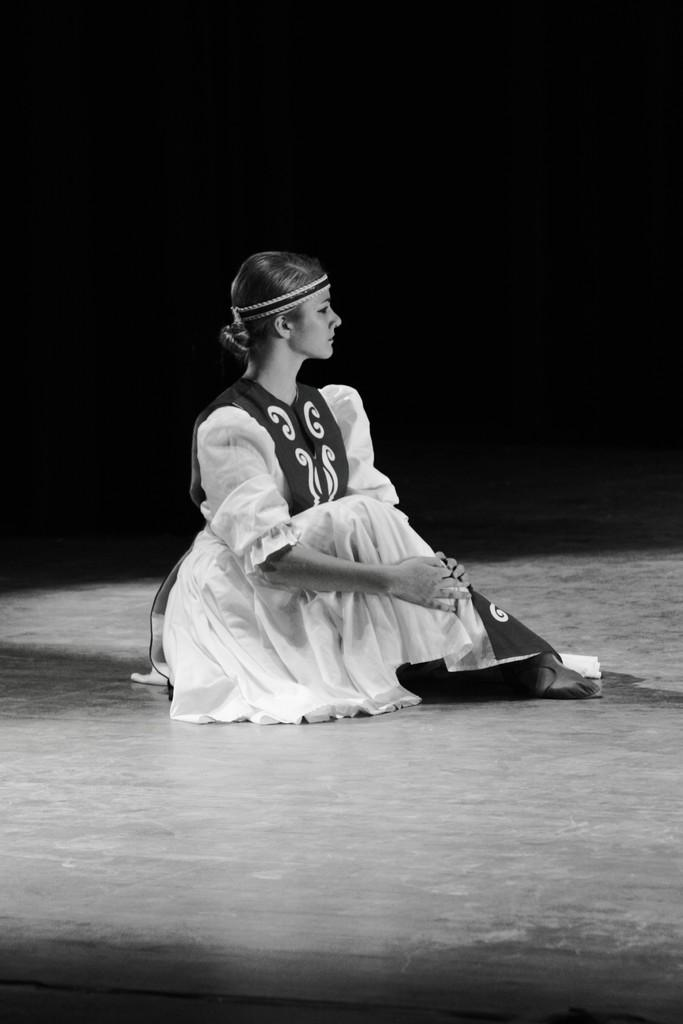What is the color scheme of the image? The image is black and white. What can be seen in the center of the image? There is a lady sitting in the center of the image. What part of the room is visible at the bottom of the image? The floor is visible at the bottom of the image. How would you describe the lighting in the image? The background of the image is dark. Can you see a monkey kissing the lady in the image? No, there is no monkey or any kissing activity depicted in the image. 